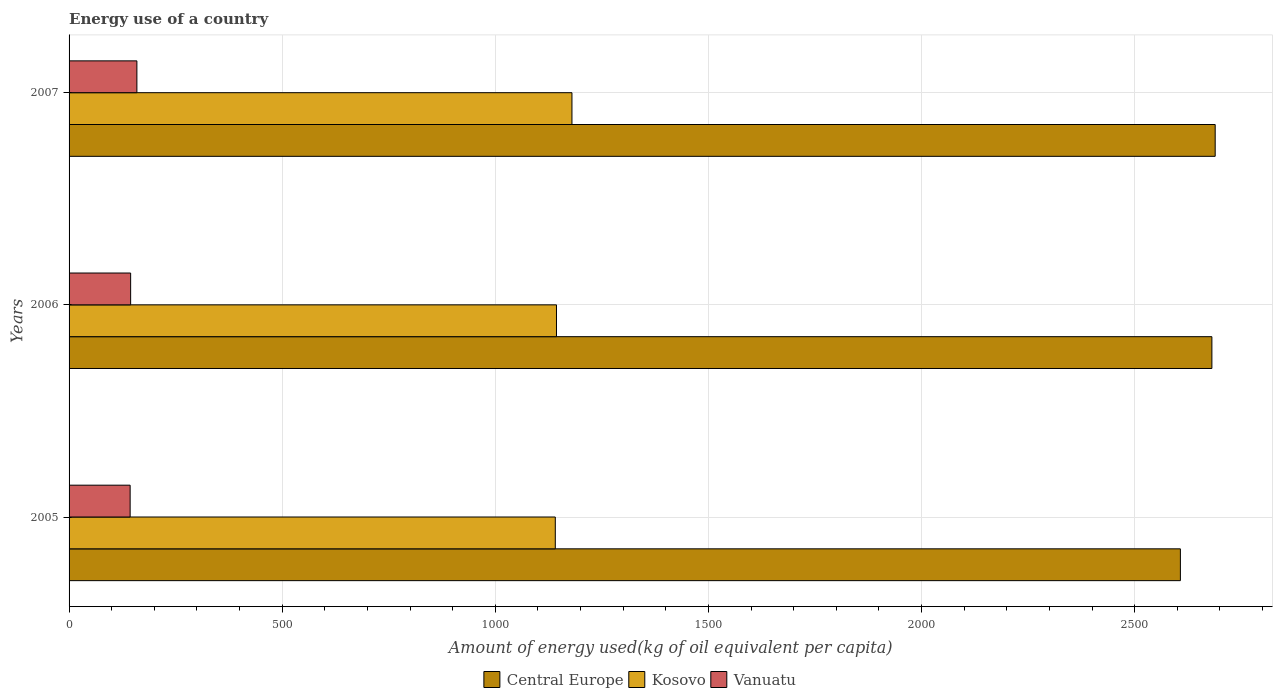Are the number of bars per tick equal to the number of legend labels?
Provide a succinct answer. Yes. How many bars are there on the 2nd tick from the top?
Your answer should be very brief. 3. How many bars are there on the 1st tick from the bottom?
Your answer should be compact. 3. In how many cases, is the number of bars for a given year not equal to the number of legend labels?
Ensure brevity in your answer.  0. What is the amount of energy used in in Central Europe in 2006?
Give a very brief answer. 2681.06. Across all years, what is the maximum amount of energy used in in Central Europe?
Your response must be concise. 2688.81. Across all years, what is the minimum amount of energy used in in Central Europe?
Your response must be concise. 2607.18. In which year was the amount of energy used in in Central Europe maximum?
Keep it short and to the point. 2007. What is the total amount of energy used in in Central Europe in the graph?
Offer a very short reply. 7977.06. What is the difference between the amount of energy used in in Kosovo in 2005 and that in 2007?
Ensure brevity in your answer.  -39.06. What is the difference between the amount of energy used in in Central Europe in 2005 and the amount of energy used in in Kosovo in 2007?
Offer a terse response. 1427.42. What is the average amount of energy used in in Kosovo per year?
Your response must be concise. 1154.65. In the year 2007, what is the difference between the amount of energy used in in Vanuatu and amount of energy used in in Kosovo?
Give a very brief answer. -1020.64. In how many years, is the amount of energy used in in Kosovo greater than 2500 kg?
Provide a short and direct response. 0. What is the ratio of the amount of energy used in in Vanuatu in 2006 to that in 2007?
Your answer should be compact. 0.91. Is the amount of energy used in in Central Europe in 2006 less than that in 2007?
Offer a very short reply. Yes. Is the difference between the amount of energy used in in Vanuatu in 2006 and 2007 greater than the difference between the amount of energy used in in Kosovo in 2006 and 2007?
Your answer should be compact. Yes. What is the difference between the highest and the second highest amount of energy used in in Central Europe?
Your response must be concise. 7.75. What is the difference between the highest and the lowest amount of energy used in in Kosovo?
Ensure brevity in your answer.  39.06. In how many years, is the amount of energy used in in Kosovo greater than the average amount of energy used in in Kosovo taken over all years?
Your answer should be compact. 1. What does the 1st bar from the top in 2005 represents?
Offer a very short reply. Vanuatu. What does the 2nd bar from the bottom in 2005 represents?
Offer a very short reply. Kosovo. How many bars are there?
Offer a very short reply. 9. Does the graph contain any zero values?
Make the answer very short. No. Does the graph contain grids?
Ensure brevity in your answer.  Yes. How many legend labels are there?
Ensure brevity in your answer.  3. What is the title of the graph?
Your answer should be very brief. Energy use of a country. What is the label or title of the X-axis?
Your response must be concise. Amount of energy used(kg of oil equivalent per capita). What is the label or title of the Y-axis?
Make the answer very short. Years. What is the Amount of energy used(kg of oil equivalent per capita) in Central Europe in 2005?
Provide a succinct answer. 2607.18. What is the Amount of energy used(kg of oil equivalent per capita) in Kosovo in 2005?
Offer a very short reply. 1140.7. What is the Amount of energy used(kg of oil equivalent per capita) of Vanuatu in 2005?
Your answer should be very brief. 143.28. What is the Amount of energy used(kg of oil equivalent per capita) in Central Europe in 2006?
Provide a succinct answer. 2681.06. What is the Amount of energy used(kg of oil equivalent per capita) in Kosovo in 2006?
Provide a succinct answer. 1143.5. What is the Amount of energy used(kg of oil equivalent per capita) of Vanuatu in 2006?
Keep it short and to the point. 144.43. What is the Amount of energy used(kg of oil equivalent per capita) of Central Europe in 2007?
Make the answer very short. 2688.81. What is the Amount of energy used(kg of oil equivalent per capita) in Kosovo in 2007?
Provide a succinct answer. 1179.76. What is the Amount of energy used(kg of oil equivalent per capita) of Vanuatu in 2007?
Keep it short and to the point. 159.12. Across all years, what is the maximum Amount of energy used(kg of oil equivalent per capita) in Central Europe?
Your response must be concise. 2688.81. Across all years, what is the maximum Amount of energy used(kg of oil equivalent per capita) in Kosovo?
Offer a very short reply. 1179.76. Across all years, what is the maximum Amount of energy used(kg of oil equivalent per capita) of Vanuatu?
Keep it short and to the point. 159.12. Across all years, what is the minimum Amount of energy used(kg of oil equivalent per capita) of Central Europe?
Keep it short and to the point. 2607.18. Across all years, what is the minimum Amount of energy used(kg of oil equivalent per capita) of Kosovo?
Provide a short and direct response. 1140.7. Across all years, what is the minimum Amount of energy used(kg of oil equivalent per capita) of Vanuatu?
Your answer should be compact. 143.28. What is the total Amount of energy used(kg of oil equivalent per capita) of Central Europe in the graph?
Offer a very short reply. 7977.06. What is the total Amount of energy used(kg of oil equivalent per capita) in Kosovo in the graph?
Offer a terse response. 3463.96. What is the total Amount of energy used(kg of oil equivalent per capita) in Vanuatu in the graph?
Keep it short and to the point. 446.84. What is the difference between the Amount of energy used(kg of oil equivalent per capita) in Central Europe in 2005 and that in 2006?
Offer a very short reply. -73.89. What is the difference between the Amount of energy used(kg of oil equivalent per capita) in Kosovo in 2005 and that in 2006?
Your answer should be compact. -2.8. What is the difference between the Amount of energy used(kg of oil equivalent per capita) in Vanuatu in 2005 and that in 2006?
Offer a very short reply. -1.15. What is the difference between the Amount of energy used(kg of oil equivalent per capita) of Central Europe in 2005 and that in 2007?
Give a very brief answer. -81.64. What is the difference between the Amount of energy used(kg of oil equivalent per capita) in Kosovo in 2005 and that in 2007?
Offer a terse response. -39.06. What is the difference between the Amount of energy used(kg of oil equivalent per capita) in Vanuatu in 2005 and that in 2007?
Provide a short and direct response. -15.84. What is the difference between the Amount of energy used(kg of oil equivalent per capita) of Central Europe in 2006 and that in 2007?
Give a very brief answer. -7.75. What is the difference between the Amount of energy used(kg of oil equivalent per capita) in Kosovo in 2006 and that in 2007?
Provide a succinct answer. -36.26. What is the difference between the Amount of energy used(kg of oil equivalent per capita) of Vanuatu in 2006 and that in 2007?
Give a very brief answer. -14.69. What is the difference between the Amount of energy used(kg of oil equivalent per capita) of Central Europe in 2005 and the Amount of energy used(kg of oil equivalent per capita) of Kosovo in 2006?
Make the answer very short. 1463.68. What is the difference between the Amount of energy used(kg of oil equivalent per capita) of Central Europe in 2005 and the Amount of energy used(kg of oil equivalent per capita) of Vanuatu in 2006?
Give a very brief answer. 2462.75. What is the difference between the Amount of energy used(kg of oil equivalent per capita) of Kosovo in 2005 and the Amount of energy used(kg of oil equivalent per capita) of Vanuatu in 2006?
Your answer should be compact. 996.27. What is the difference between the Amount of energy used(kg of oil equivalent per capita) in Central Europe in 2005 and the Amount of energy used(kg of oil equivalent per capita) in Kosovo in 2007?
Offer a terse response. 1427.42. What is the difference between the Amount of energy used(kg of oil equivalent per capita) in Central Europe in 2005 and the Amount of energy used(kg of oil equivalent per capita) in Vanuatu in 2007?
Offer a terse response. 2448.06. What is the difference between the Amount of energy used(kg of oil equivalent per capita) of Kosovo in 2005 and the Amount of energy used(kg of oil equivalent per capita) of Vanuatu in 2007?
Give a very brief answer. 981.58. What is the difference between the Amount of energy used(kg of oil equivalent per capita) in Central Europe in 2006 and the Amount of energy used(kg of oil equivalent per capita) in Kosovo in 2007?
Make the answer very short. 1501.31. What is the difference between the Amount of energy used(kg of oil equivalent per capita) of Central Europe in 2006 and the Amount of energy used(kg of oil equivalent per capita) of Vanuatu in 2007?
Ensure brevity in your answer.  2521.94. What is the difference between the Amount of energy used(kg of oil equivalent per capita) in Kosovo in 2006 and the Amount of energy used(kg of oil equivalent per capita) in Vanuatu in 2007?
Offer a very short reply. 984.38. What is the average Amount of energy used(kg of oil equivalent per capita) in Central Europe per year?
Keep it short and to the point. 2659.02. What is the average Amount of energy used(kg of oil equivalent per capita) of Kosovo per year?
Your response must be concise. 1154.65. What is the average Amount of energy used(kg of oil equivalent per capita) of Vanuatu per year?
Make the answer very short. 148.95. In the year 2005, what is the difference between the Amount of energy used(kg of oil equivalent per capita) in Central Europe and Amount of energy used(kg of oil equivalent per capita) in Kosovo?
Offer a very short reply. 1466.48. In the year 2005, what is the difference between the Amount of energy used(kg of oil equivalent per capita) in Central Europe and Amount of energy used(kg of oil equivalent per capita) in Vanuatu?
Your answer should be very brief. 2463.9. In the year 2005, what is the difference between the Amount of energy used(kg of oil equivalent per capita) in Kosovo and Amount of energy used(kg of oil equivalent per capita) in Vanuatu?
Provide a short and direct response. 997.42. In the year 2006, what is the difference between the Amount of energy used(kg of oil equivalent per capita) in Central Europe and Amount of energy used(kg of oil equivalent per capita) in Kosovo?
Ensure brevity in your answer.  1537.56. In the year 2006, what is the difference between the Amount of energy used(kg of oil equivalent per capita) of Central Europe and Amount of energy used(kg of oil equivalent per capita) of Vanuatu?
Your response must be concise. 2536.63. In the year 2006, what is the difference between the Amount of energy used(kg of oil equivalent per capita) of Kosovo and Amount of energy used(kg of oil equivalent per capita) of Vanuatu?
Make the answer very short. 999.07. In the year 2007, what is the difference between the Amount of energy used(kg of oil equivalent per capita) of Central Europe and Amount of energy used(kg of oil equivalent per capita) of Kosovo?
Ensure brevity in your answer.  1509.06. In the year 2007, what is the difference between the Amount of energy used(kg of oil equivalent per capita) of Central Europe and Amount of energy used(kg of oil equivalent per capita) of Vanuatu?
Give a very brief answer. 2529.69. In the year 2007, what is the difference between the Amount of energy used(kg of oil equivalent per capita) of Kosovo and Amount of energy used(kg of oil equivalent per capita) of Vanuatu?
Offer a terse response. 1020.64. What is the ratio of the Amount of energy used(kg of oil equivalent per capita) in Central Europe in 2005 to that in 2006?
Offer a very short reply. 0.97. What is the ratio of the Amount of energy used(kg of oil equivalent per capita) of Kosovo in 2005 to that in 2006?
Keep it short and to the point. 1. What is the ratio of the Amount of energy used(kg of oil equivalent per capita) in Central Europe in 2005 to that in 2007?
Keep it short and to the point. 0.97. What is the ratio of the Amount of energy used(kg of oil equivalent per capita) in Kosovo in 2005 to that in 2007?
Your response must be concise. 0.97. What is the ratio of the Amount of energy used(kg of oil equivalent per capita) in Vanuatu in 2005 to that in 2007?
Give a very brief answer. 0.9. What is the ratio of the Amount of energy used(kg of oil equivalent per capita) in Kosovo in 2006 to that in 2007?
Offer a very short reply. 0.97. What is the ratio of the Amount of energy used(kg of oil equivalent per capita) in Vanuatu in 2006 to that in 2007?
Give a very brief answer. 0.91. What is the difference between the highest and the second highest Amount of energy used(kg of oil equivalent per capita) in Central Europe?
Provide a succinct answer. 7.75. What is the difference between the highest and the second highest Amount of energy used(kg of oil equivalent per capita) of Kosovo?
Offer a terse response. 36.26. What is the difference between the highest and the second highest Amount of energy used(kg of oil equivalent per capita) of Vanuatu?
Your response must be concise. 14.69. What is the difference between the highest and the lowest Amount of energy used(kg of oil equivalent per capita) in Central Europe?
Give a very brief answer. 81.64. What is the difference between the highest and the lowest Amount of energy used(kg of oil equivalent per capita) of Kosovo?
Your answer should be very brief. 39.06. What is the difference between the highest and the lowest Amount of energy used(kg of oil equivalent per capita) of Vanuatu?
Your answer should be compact. 15.84. 